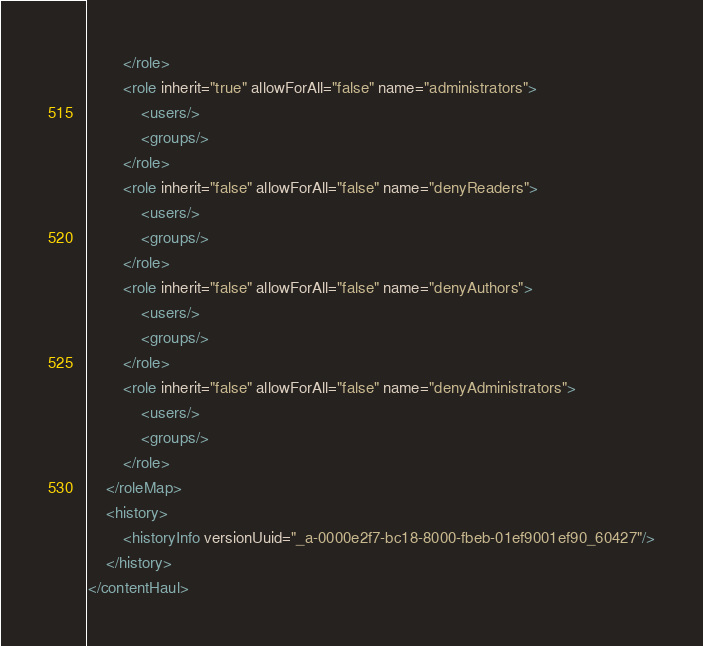Convert code to text. <code><loc_0><loc_0><loc_500><loc_500><_XML_>        </role>
        <role inherit="true" allowForAll="false" name="administrators">
            <users/>
            <groups/>
        </role>
        <role inherit="false" allowForAll="false" name="denyReaders">
            <users/>
            <groups/>
        </role>
        <role inherit="false" allowForAll="false" name="denyAuthors">
            <users/>
            <groups/>
        </role>
        <role inherit="false" allowForAll="false" name="denyAdministrators">
            <users/>
            <groups/>
        </role>
    </roleMap>
    <history>
        <historyInfo versionUuid="_a-0000e2f7-bc18-8000-fbeb-01ef9001ef90_60427"/>
    </history>
</contentHaul>
</code> 